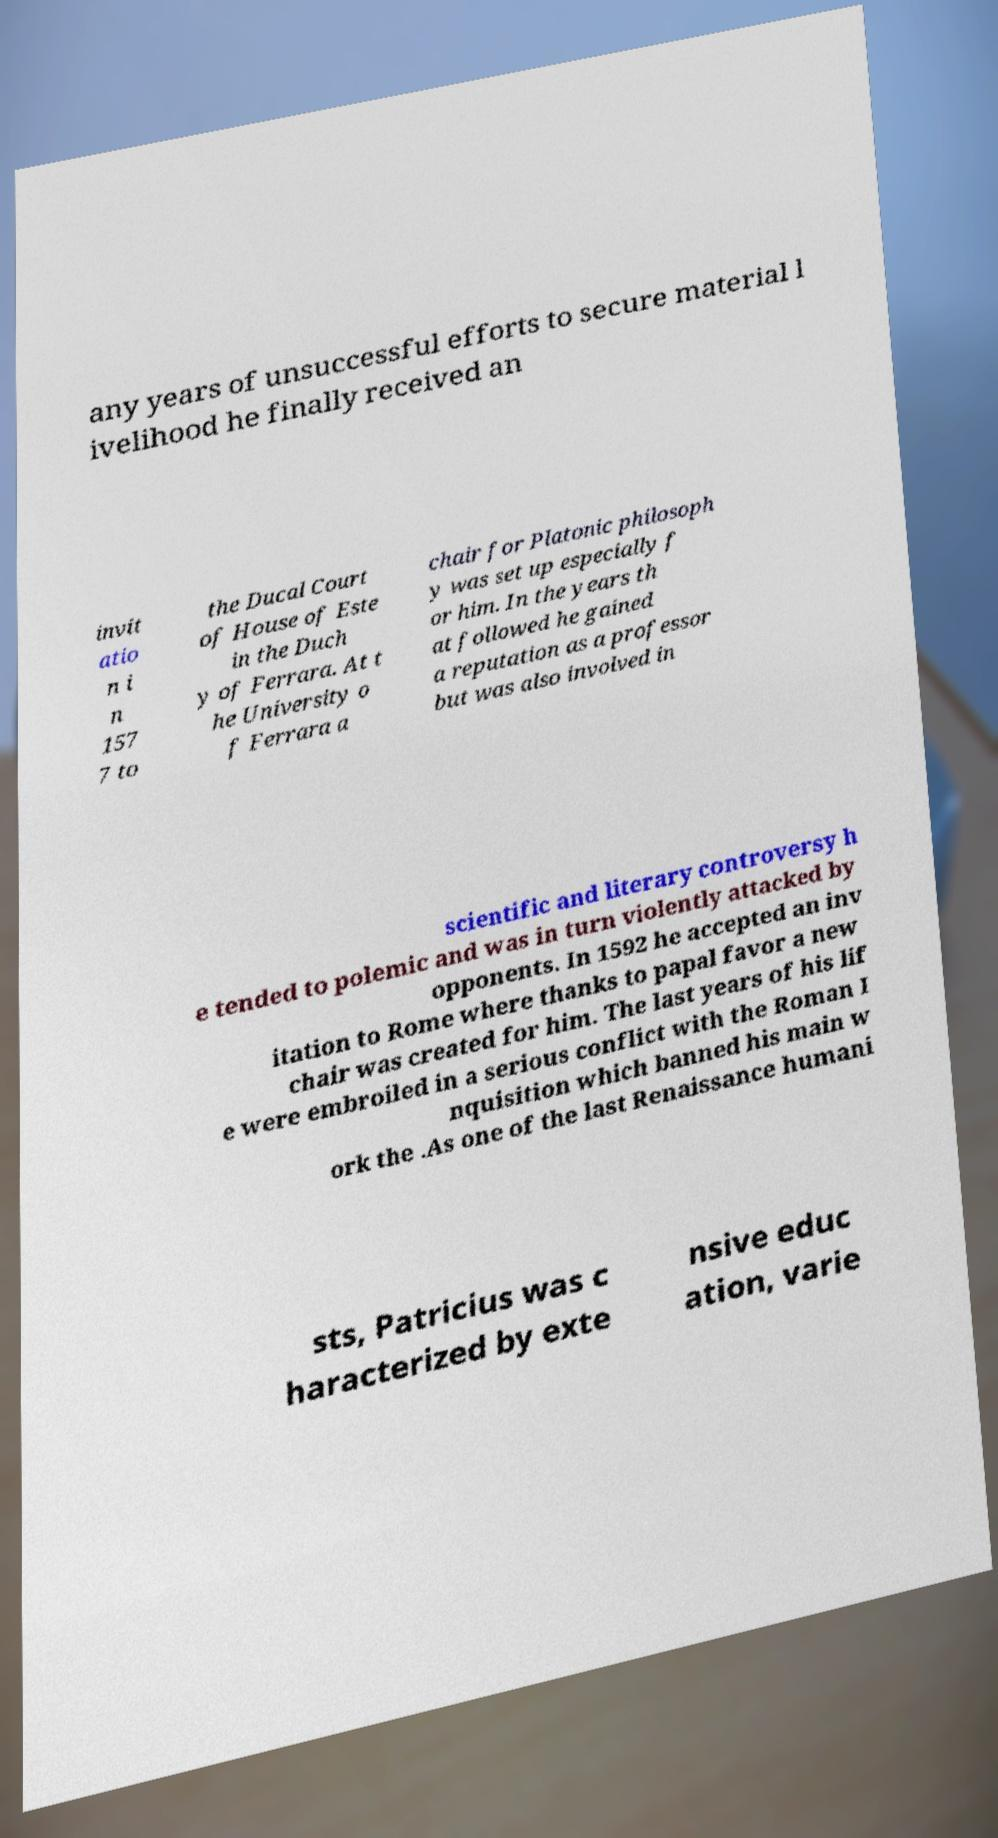What messages or text are displayed in this image? I need them in a readable, typed format. any years of unsuccessful efforts to secure material l ivelihood he finally received an invit atio n i n 157 7 to the Ducal Court of House of Este in the Duch y of Ferrara. At t he University o f Ferrara a chair for Platonic philosoph y was set up especially f or him. In the years th at followed he gained a reputation as a professor but was also involved in scientific and literary controversy h e tended to polemic and was in turn violently attacked by opponents. In 1592 he accepted an inv itation to Rome where thanks to papal favor a new chair was created for him. The last years of his lif e were embroiled in a serious conflict with the Roman I nquisition which banned his main w ork the .As one of the last Renaissance humani sts, Patricius was c haracterized by exte nsive educ ation, varie 